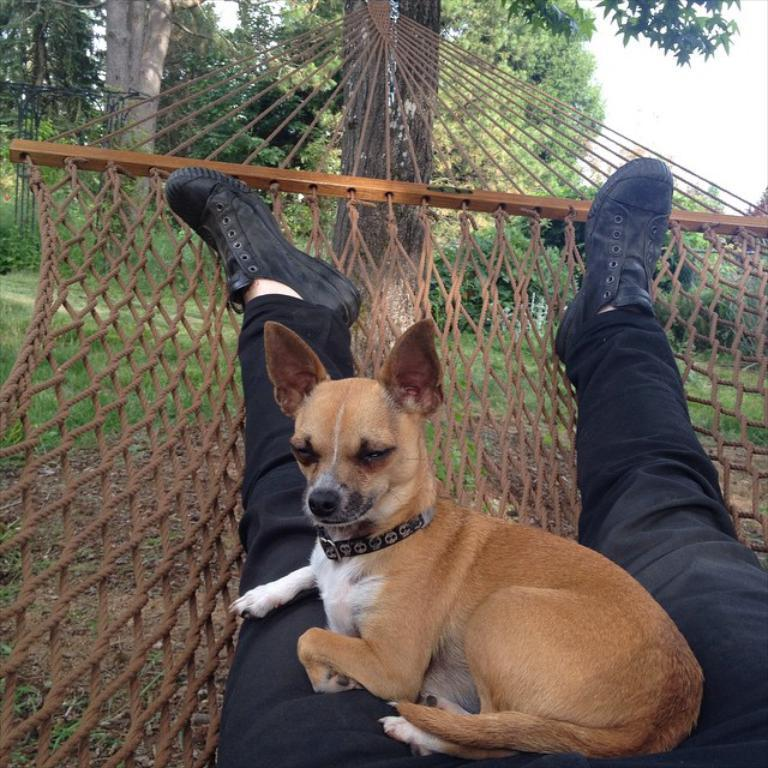Who or what can be seen in the image with the person? There is a dog in the image with the person. What are the person and dog doing in the image? The person and dog are lying on a hammock in the image. How is the hammock supported in the image? The hammock is tied to a tree in the image. What type of natural environment is visible in the background of the image? Trees, grass, and the sky are visible in the background of the image. What type of boundary can be seen in the image? There is no boundary visible in the image; it features a person, a dog, and a hammock in a natural environment. 